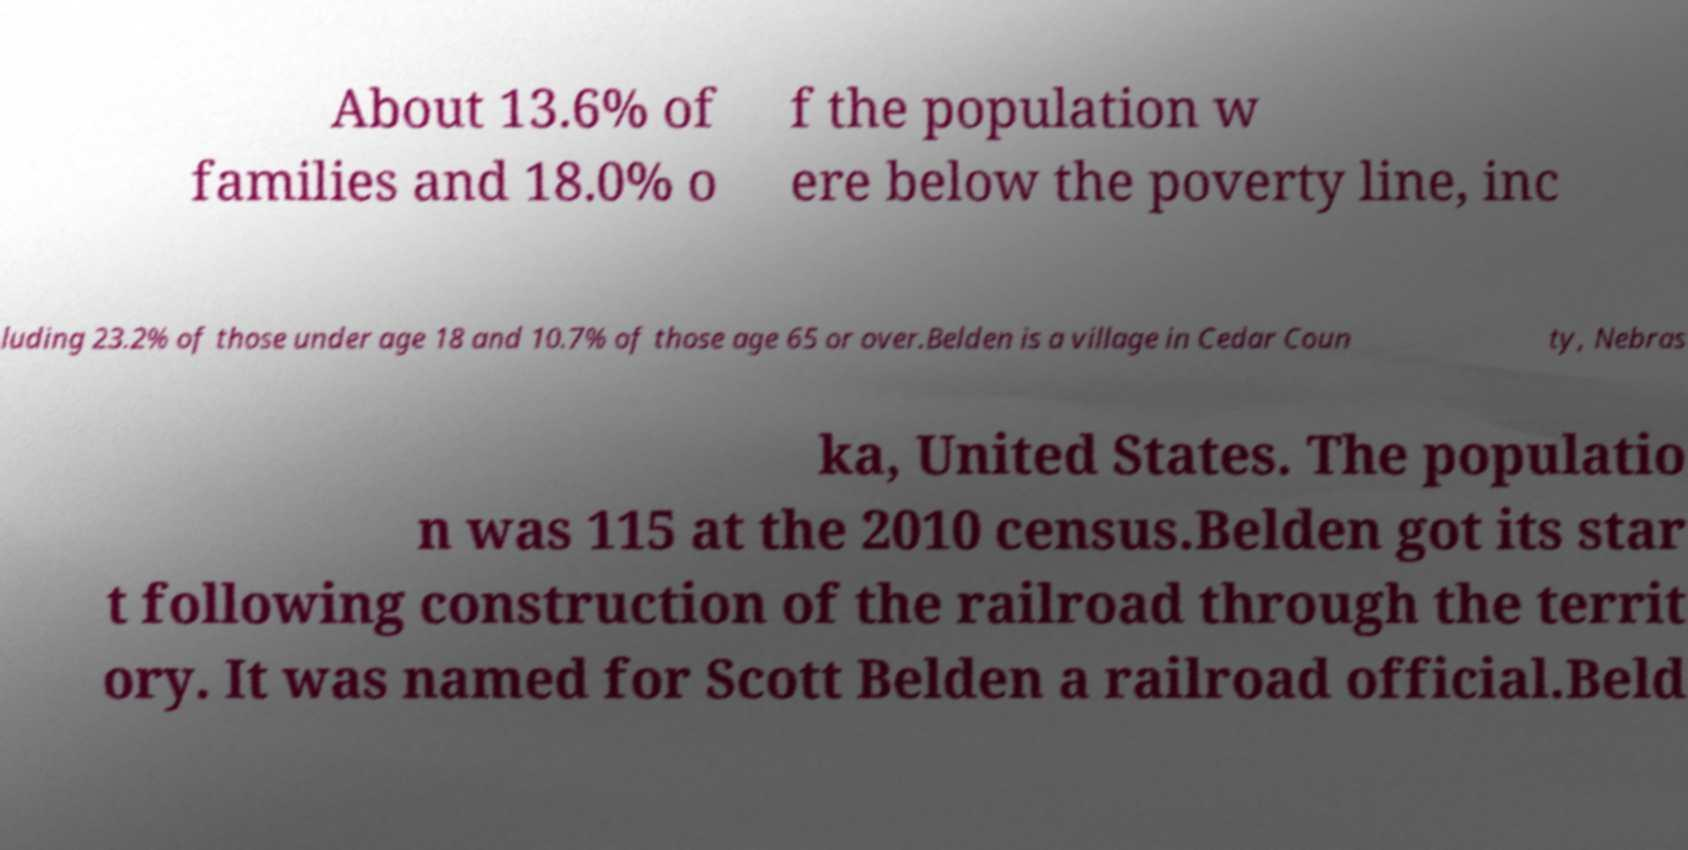Could you assist in decoding the text presented in this image and type it out clearly? About 13.6% of families and 18.0% o f the population w ere below the poverty line, inc luding 23.2% of those under age 18 and 10.7% of those age 65 or over.Belden is a village in Cedar Coun ty, Nebras ka, United States. The populatio n was 115 at the 2010 census.Belden got its star t following construction of the railroad through the territ ory. It was named for Scott Belden a railroad official.Beld 